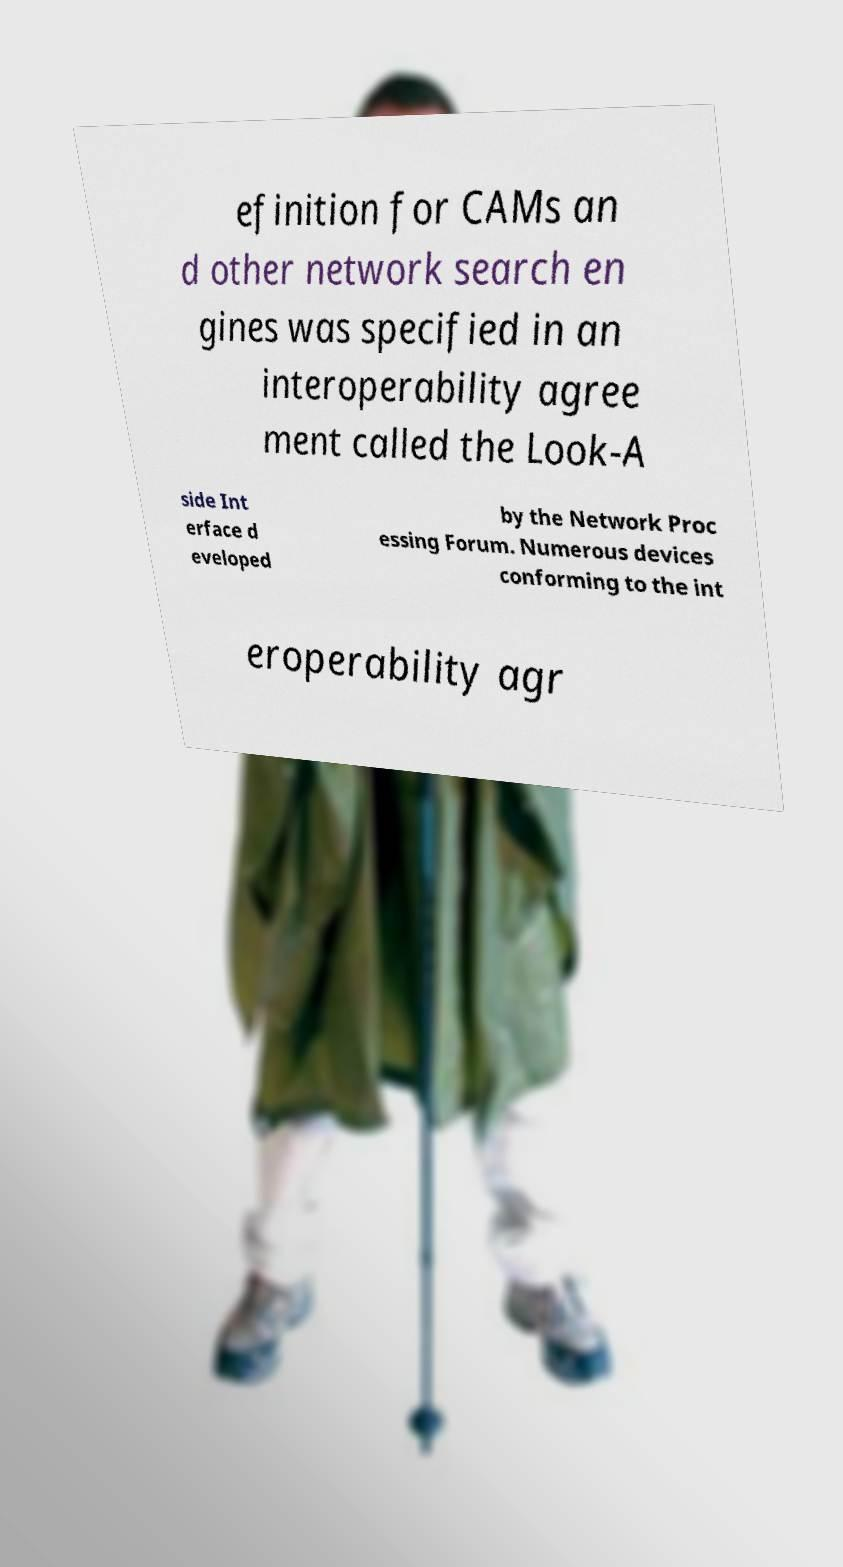I need the written content from this picture converted into text. Can you do that? efinition for CAMs an d other network search en gines was specified in an interoperability agree ment called the Look-A side Int erface d eveloped by the Network Proc essing Forum. Numerous devices conforming to the int eroperability agr 